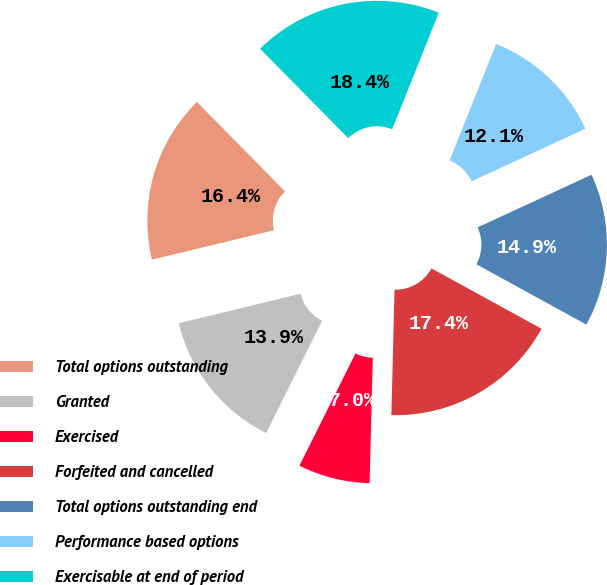<chart> <loc_0><loc_0><loc_500><loc_500><pie_chart><fcel>Total options outstanding<fcel>Granted<fcel>Exercised<fcel>Forfeited and cancelled<fcel>Total options outstanding end<fcel>Performance based options<fcel>Exercisable at end of period<nl><fcel>16.39%<fcel>13.85%<fcel>6.97%<fcel>17.42%<fcel>14.87%<fcel>12.06%<fcel>18.44%<nl></chart> 